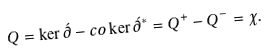<formula> <loc_0><loc_0><loc_500><loc_500>Q = \ker \acute { \partial } - c o \ker \acute { \partial } ^ { \ast } = Q ^ { + } - Q ^ { - } = \chi .</formula> 